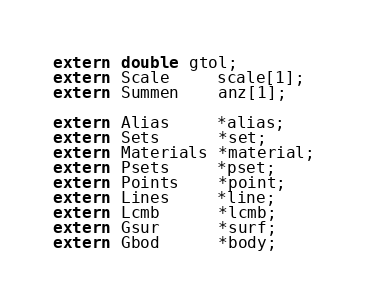<code> <loc_0><loc_0><loc_500><loc_500><_C_>extern double gtol;
extern Scale     scale[1];
extern Summen    anz[1];

extern Alias     *alias;
extern Sets      *set;
extern Materials *material; 
extern Psets     *pset;
extern Points    *point;
extern Lines     *line;
extern Lcmb      *lcmb;
extern Gsur      *surf;
extern Gbod      *body;</code> 